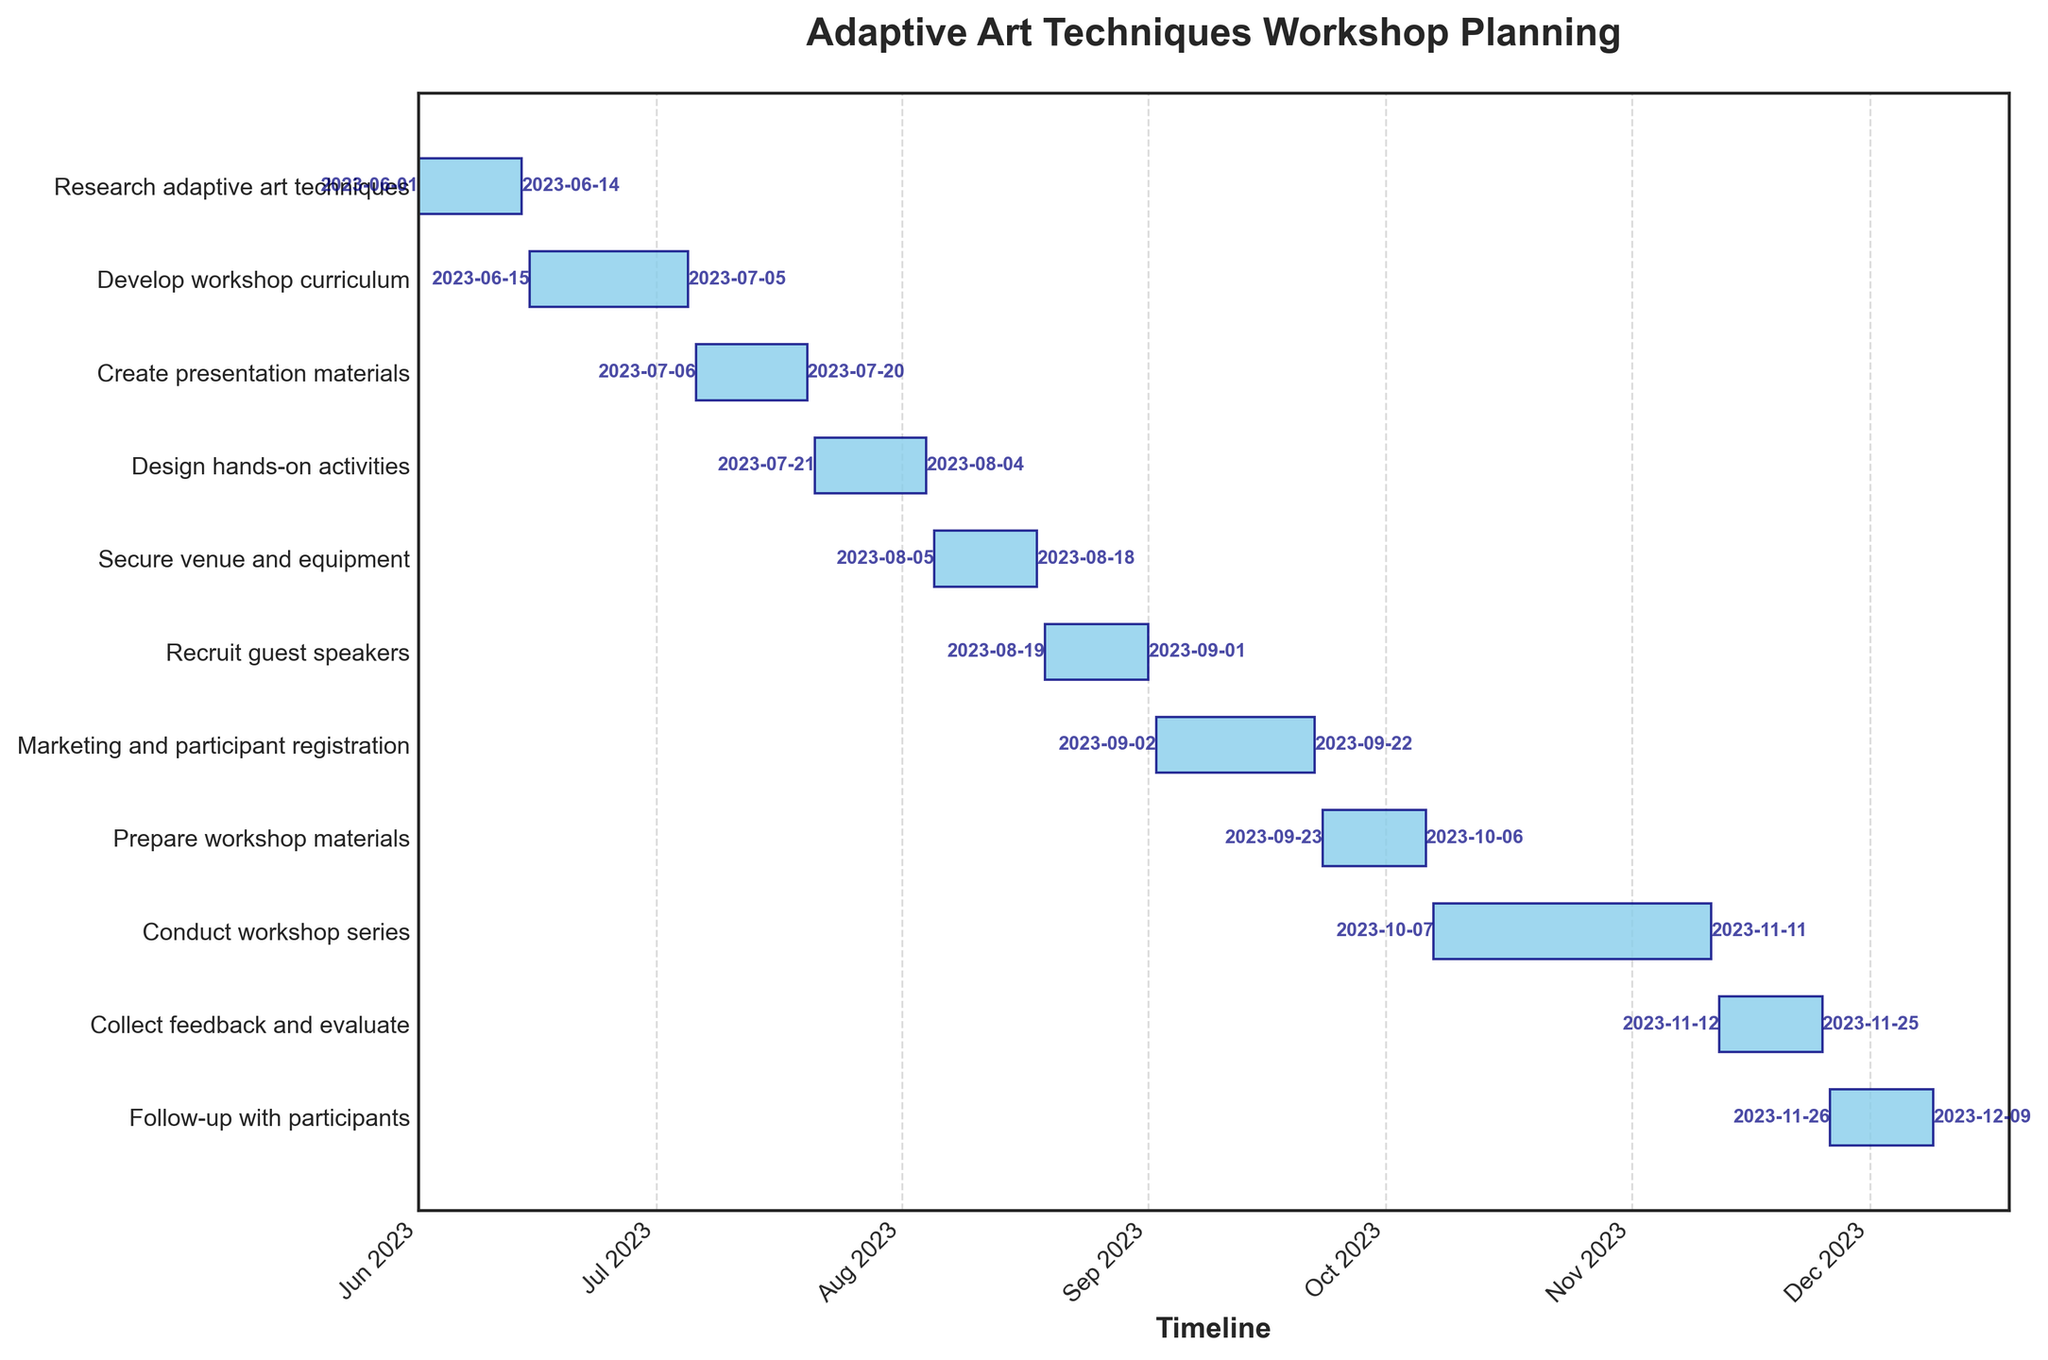What tasks are planned for August? To determine the tasks planned for August, look at the sections of the Gantt chart spanning the timeframe of August. The bars and their labels within this period indicate the tasks. From the figure, "Secure venue and equipment" and "Recruit guest speakers" are the tasks planned for August.
Answer: Secure venue and equipment, Recruit guest speakers When does the “Develop workshop curriculum” task start and end? Locate the “Develop workshop curriculum” bar in the Gantt chart. Identify the start and end dates marked alongside the bar. The bar starts from June 15, 2023, and ends on July 5, 2023.
Answer: June 15, 2023 - July 5, 2023 How many days is the “Conduct workshop series” scheduled to take? Find the “Conduct workshop series” bar and check the duration value attached to it. The duration is marked as 36 days in the chart.
Answer: 36 days Which task takes the longest duration, and what is its duration? To find the longest task, compare the lengths of all bars. The longest bar indicates the task with the longest duration. The "Conduct workshop series" task has the longest duration with 36 days.
Answer: Conduct workshop series, 36 days How many tasks are there in total? Count the number of bars in the Gantt chart, as each bar represents a task. There are 11 bars in total.
Answer: 11 tasks What is the final task in the project and when does it end? Look for the last bar in the Gantt chart and read its label. The final task is "Follow-up with participants," and the end date for this task, as indicated, is December 9, 2023.
Answer: Follow-up with participants, December 9, 2023 What is the total duration from the start of the first task to the end of the last task? Identify the start date of the first task, "Research adaptive art techniques" (June 1, 2023), and the end date of the last task, "Follow-up with participants" (December 9, 2023). Calculate the days between these two dates. From June 1, 2023, to December 9, 2023, is 192 days.
Answer: 192 days Which tasks overlap with the "Design hands-on activities" task? Find the "Design hands-on activities" bar on the Gantt chart. Then, identify other tasks whose bars overlap with this task's timeframe from July 21, 2023, to August 4, 2023. The overlapping tasks are "Create presentation materials" and "Secure venue and equipment."
Answer: Create presentation materials, Secure venue and equipment What is the combined duration of the first three tasks? Sum the durations of the first three tasks: "Research adaptive art techniques" (14 days), "Develop workshop curriculum" (21 days), and "Create presentation materials" (15 days). The combined duration is 14 + 21 + 15 = 50 days.
Answer: 50 days Which tasks are dedicated to preparatory work before the actual workshop series starts? Identify tasks before the "Conduct workshop series" in the Gantt chart. These tasks include "Research adaptive art techniques," "Develop workshop curriculum," "Create presentation materials," "Design hands-on activities," "Secure venue and equipment," "Recruit guest speakers," "Marketing and participant registration," and "Prepare workshop materials."
Answer: Research adaptive art techniques, Develop workshop curriculum, Create presentation materials, Design hands-on activities, Secure venue and equipment, Recruit guest speakers, Marketing and participant registration, Prepare workshop materials 